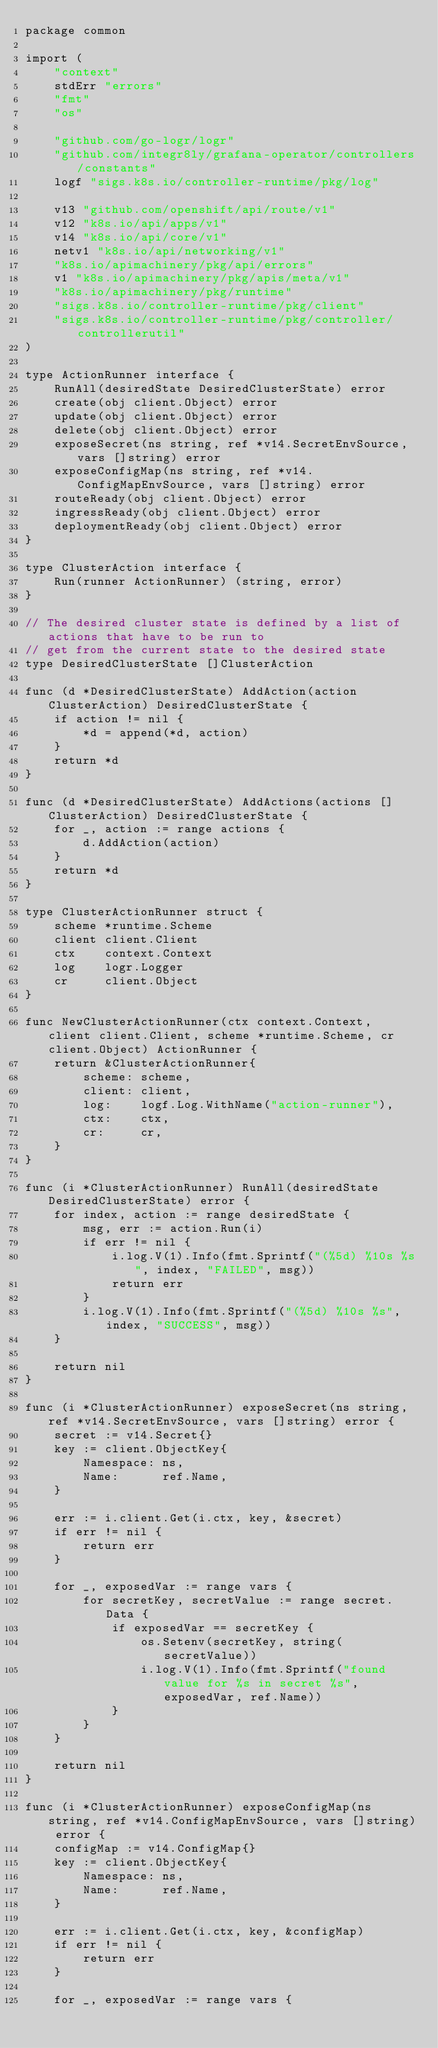<code> <loc_0><loc_0><loc_500><loc_500><_Go_>package common

import (
	"context"
	stdErr "errors"
	"fmt"
	"os"

	"github.com/go-logr/logr"
	"github.com/integr8ly/grafana-operator/controllers/constants"
	logf "sigs.k8s.io/controller-runtime/pkg/log"

	v13 "github.com/openshift/api/route/v1"
	v12 "k8s.io/api/apps/v1"
	v14 "k8s.io/api/core/v1"
	netv1 "k8s.io/api/networking/v1"
	"k8s.io/apimachinery/pkg/api/errors"
	v1 "k8s.io/apimachinery/pkg/apis/meta/v1"
	"k8s.io/apimachinery/pkg/runtime"
	"sigs.k8s.io/controller-runtime/pkg/client"
	"sigs.k8s.io/controller-runtime/pkg/controller/controllerutil"
)

type ActionRunner interface {
	RunAll(desiredState DesiredClusterState) error
	create(obj client.Object) error
	update(obj client.Object) error
	delete(obj client.Object) error
	exposeSecret(ns string, ref *v14.SecretEnvSource, vars []string) error
	exposeConfigMap(ns string, ref *v14.ConfigMapEnvSource, vars []string) error
	routeReady(obj client.Object) error
	ingressReady(obj client.Object) error
	deploymentReady(obj client.Object) error
}

type ClusterAction interface {
	Run(runner ActionRunner) (string, error)
}

// The desired cluster state is defined by a list of actions that have to be run to
// get from the current state to the desired state
type DesiredClusterState []ClusterAction

func (d *DesiredClusterState) AddAction(action ClusterAction) DesiredClusterState {
	if action != nil {
		*d = append(*d, action)
	}
	return *d
}

func (d *DesiredClusterState) AddActions(actions []ClusterAction) DesiredClusterState {
	for _, action := range actions {
		d.AddAction(action)
	}
	return *d
}

type ClusterActionRunner struct {
	scheme *runtime.Scheme
	client client.Client
	ctx    context.Context
	log    logr.Logger
	cr     client.Object
}

func NewClusterActionRunner(ctx context.Context, client client.Client, scheme *runtime.Scheme, cr client.Object) ActionRunner {
	return &ClusterActionRunner{
		scheme: scheme,
		client: client,
		log:    logf.Log.WithName("action-runner"),
		ctx:    ctx,
		cr:     cr,
	}
}

func (i *ClusterActionRunner) RunAll(desiredState DesiredClusterState) error {
	for index, action := range desiredState {
		msg, err := action.Run(i)
		if err != nil {
			i.log.V(1).Info(fmt.Sprintf("(%5d) %10s %s", index, "FAILED", msg))
			return err
		}
		i.log.V(1).Info(fmt.Sprintf("(%5d) %10s %s", index, "SUCCESS", msg))
	}

	return nil
}

func (i *ClusterActionRunner) exposeSecret(ns string, ref *v14.SecretEnvSource, vars []string) error {
	secret := v14.Secret{}
	key := client.ObjectKey{
		Namespace: ns,
		Name:      ref.Name,
	}

	err := i.client.Get(i.ctx, key, &secret)
	if err != nil {
		return err
	}

	for _, exposedVar := range vars {
		for secretKey, secretValue := range secret.Data {
			if exposedVar == secretKey {
				os.Setenv(secretKey, string(secretValue))
				i.log.V(1).Info(fmt.Sprintf("found value for %s in secret %s", exposedVar, ref.Name))
			}
		}
	}

	return nil
}

func (i *ClusterActionRunner) exposeConfigMap(ns string, ref *v14.ConfigMapEnvSource, vars []string) error {
	configMap := v14.ConfigMap{}
	key := client.ObjectKey{
		Namespace: ns,
		Name:      ref.Name,
	}

	err := i.client.Get(i.ctx, key, &configMap)
	if err != nil {
		return err
	}

	for _, exposedVar := range vars {</code> 